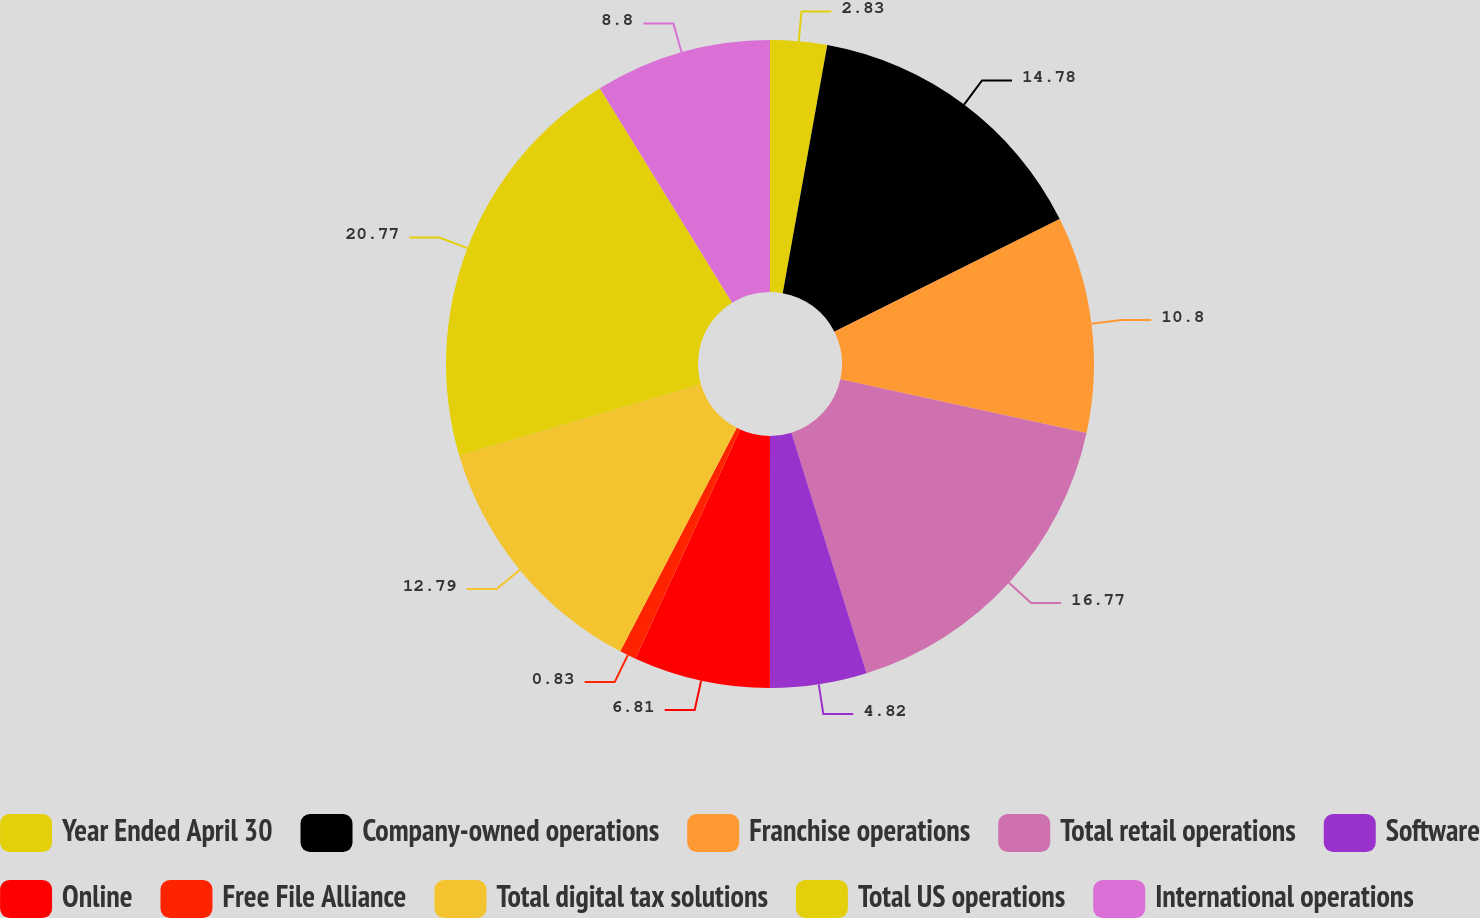Convert chart. <chart><loc_0><loc_0><loc_500><loc_500><pie_chart><fcel>Year Ended April 30<fcel>Company-owned operations<fcel>Franchise operations<fcel>Total retail operations<fcel>Software<fcel>Online<fcel>Free File Alliance<fcel>Total digital tax solutions<fcel>Total US operations<fcel>International operations<nl><fcel>2.83%<fcel>14.78%<fcel>10.8%<fcel>16.77%<fcel>4.82%<fcel>6.81%<fcel>0.83%<fcel>12.79%<fcel>20.76%<fcel>8.8%<nl></chart> 